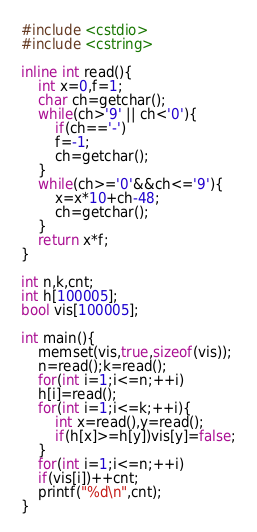<code> <loc_0><loc_0><loc_500><loc_500><_C++_>#include <cstdio>
#include <cstring>

inline int read(){
	int x=0,f=1;
	char ch=getchar();
	while(ch>'9' || ch<'0'){
		if(ch=='-')
		f=-1;
		ch=getchar();
	}
	while(ch>='0'&&ch<='9'){
		x=x*10+ch-48;
		ch=getchar();
	}
	return x*f;
}

int n,k,cnt;
int h[100005];
bool vis[100005];

int main(){
	memset(vis,true,sizeof(vis));
	n=read();k=read();
	for(int i=1;i<=n;++i)
	h[i]=read();
	for(int i=1;i<=k;++i){
		int x=read(),y=read();
		if(h[x]>=h[y])vis[y]=false;
	}
	for(int i=1;i<=n;++i)
	if(vis[i])++cnt;
	printf("%d\n",cnt);
}</code> 